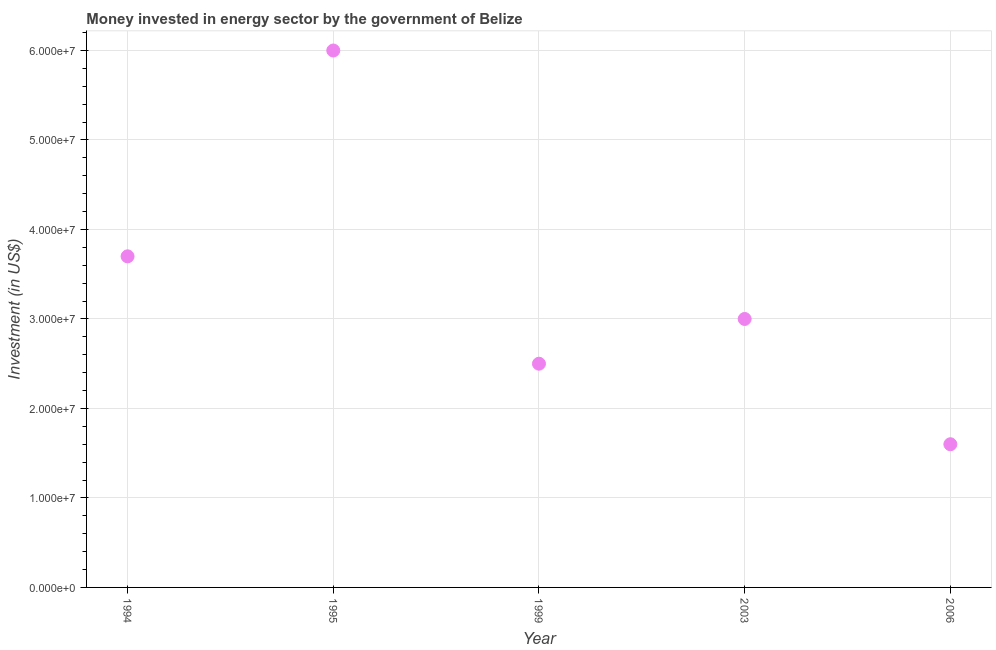What is the investment in energy in 1994?
Offer a terse response. 3.70e+07. Across all years, what is the maximum investment in energy?
Your response must be concise. 6.00e+07. Across all years, what is the minimum investment in energy?
Your answer should be very brief. 1.60e+07. In which year was the investment in energy maximum?
Ensure brevity in your answer.  1995. In which year was the investment in energy minimum?
Ensure brevity in your answer.  2006. What is the sum of the investment in energy?
Give a very brief answer. 1.68e+08. What is the difference between the investment in energy in 1994 and 2006?
Keep it short and to the point. 2.10e+07. What is the average investment in energy per year?
Your answer should be very brief. 3.36e+07. What is the median investment in energy?
Your answer should be compact. 3.00e+07. In how many years, is the investment in energy greater than 44000000 US$?
Provide a succinct answer. 1. What is the ratio of the investment in energy in 2003 to that in 2006?
Make the answer very short. 1.88. Is the investment in energy in 1994 less than that in 1995?
Your response must be concise. Yes. What is the difference between the highest and the second highest investment in energy?
Provide a succinct answer. 2.30e+07. Is the sum of the investment in energy in 1994 and 2003 greater than the maximum investment in energy across all years?
Offer a very short reply. Yes. What is the difference between the highest and the lowest investment in energy?
Your answer should be very brief. 4.40e+07. How many dotlines are there?
Make the answer very short. 1. How many years are there in the graph?
Provide a succinct answer. 5. Does the graph contain grids?
Your answer should be very brief. Yes. What is the title of the graph?
Make the answer very short. Money invested in energy sector by the government of Belize. What is the label or title of the Y-axis?
Offer a terse response. Investment (in US$). What is the Investment (in US$) in 1994?
Make the answer very short. 3.70e+07. What is the Investment (in US$) in 1995?
Your answer should be very brief. 6.00e+07. What is the Investment (in US$) in 1999?
Offer a terse response. 2.50e+07. What is the Investment (in US$) in 2003?
Provide a succinct answer. 3.00e+07. What is the Investment (in US$) in 2006?
Offer a terse response. 1.60e+07. What is the difference between the Investment (in US$) in 1994 and 1995?
Provide a short and direct response. -2.30e+07. What is the difference between the Investment (in US$) in 1994 and 1999?
Your response must be concise. 1.20e+07. What is the difference between the Investment (in US$) in 1994 and 2003?
Offer a very short reply. 7.00e+06. What is the difference between the Investment (in US$) in 1994 and 2006?
Give a very brief answer. 2.10e+07. What is the difference between the Investment (in US$) in 1995 and 1999?
Keep it short and to the point. 3.50e+07. What is the difference between the Investment (in US$) in 1995 and 2003?
Make the answer very short. 3.00e+07. What is the difference between the Investment (in US$) in 1995 and 2006?
Offer a very short reply. 4.40e+07. What is the difference between the Investment (in US$) in 1999 and 2003?
Your response must be concise. -5.00e+06. What is the difference between the Investment (in US$) in 1999 and 2006?
Provide a succinct answer. 9.00e+06. What is the difference between the Investment (in US$) in 2003 and 2006?
Provide a short and direct response. 1.40e+07. What is the ratio of the Investment (in US$) in 1994 to that in 1995?
Ensure brevity in your answer.  0.62. What is the ratio of the Investment (in US$) in 1994 to that in 1999?
Your response must be concise. 1.48. What is the ratio of the Investment (in US$) in 1994 to that in 2003?
Offer a terse response. 1.23. What is the ratio of the Investment (in US$) in 1994 to that in 2006?
Provide a succinct answer. 2.31. What is the ratio of the Investment (in US$) in 1995 to that in 2003?
Ensure brevity in your answer.  2. What is the ratio of the Investment (in US$) in 1995 to that in 2006?
Keep it short and to the point. 3.75. What is the ratio of the Investment (in US$) in 1999 to that in 2003?
Your answer should be compact. 0.83. What is the ratio of the Investment (in US$) in 1999 to that in 2006?
Keep it short and to the point. 1.56. What is the ratio of the Investment (in US$) in 2003 to that in 2006?
Provide a succinct answer. 1.88. 